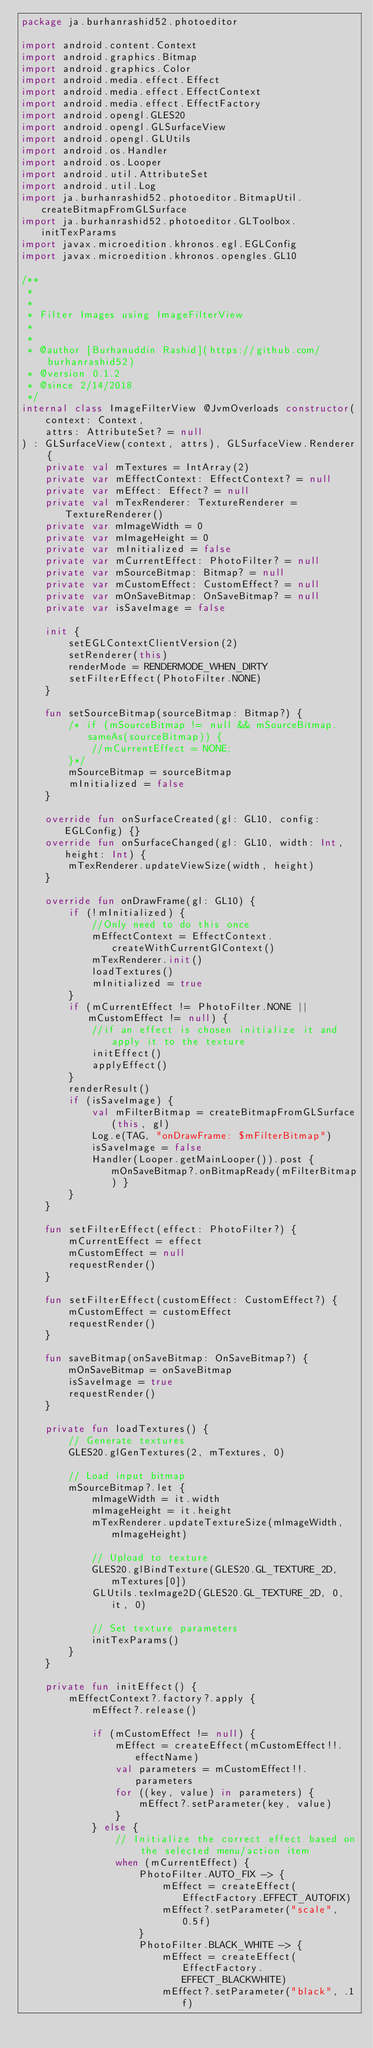<code> <loc_0><loc_0><loc_500><loc_500><_Kotlin_>package ja.burhanrashid52.photoeditor

import android.content.Context
import android.graphics.Bitmap
import android.graphics.Color
import android.media.effect.Effect
import android.media.effect.EffectContext
import android.media.effect.EffectFactory
import android.opengl.GLES20
import android.opengl.GLSurfaceView
import android.opengl.GLUtils
import android.os.Handler
import android.os.Looper
import android.util.AttributeSet
import android.util.Log
import ja.burhanrashid52.photoeditor.BitmapUtil.createBitmapFromGLSurface
import ja.burhanrashid52.photoeditor.GLToolbox.initTexParams
import javax.microedition.khronos.egl.EGLConfig
import javax.microedition.khronos.opengles.GL10

/**
 *
 *
 * Filter Images using ImageFilterView
 *
 *
 * @author [Burhanuddin Rashid](https://github.com/burhanrashid52)
 * @version 0.1.2
 * @since 2/14/2018
 */
internal class ImageFilterView @JvmOverloads constructor(
    context: Context,
    attrs: AttributeSet? = null
) : GLSurfaceView(context, attrs), GLSurfaceView.Renderer {
    private val mTextures = IntArray(2)
    private var mEffectContext: EffectContext? = null
    private var mEffect: Effect? = null
    private val mTexRenderer: TextureRenderer = TextureRenderer()
    private var mImageWidth = 0
    private var mImageHeight = 0
    private var mInitialized = false
    private var mCurrentEffect: PhotoFilter? = null
    private var mSourceBitmap: Bitmap? = null
    private var mCustomEffect: CustomEffect? = null
    private var mOnSaveBitmap: OnSaveBitmap? = null
    private var isSaveImage = false

    init {
        setEGLContextClientVersion(2)
        setRenderer(this)
        renderMode = RENDERMODE_WHEN_DIRTY
        setFilterEffect(PhotoFilter.NONE)
    }

    fun setSourceBitmap(sourceBitmap: Bitmap?) {
        /* if (mSourceBitmap != null && mSourceBitmap.sameAs(sourceBitmap)) {
            //mCurrentEffect = NONE;
        }*/
        mSourceBitmap = sourceBitmap
        mInitialized = false
    }

    override fun onSurfaceCreated(gl: GL10, config: EGLConfig) {}
    override fun onSurfaceChanged(gl: GL10, width: Int, height: Int) {
        mTexRenderer.updateViewSize(width, height)
    }

    override fun onDrawFrame(gl: GL10) {
        if (!mInitialized) {
            //Only need to do this once
            mEffectContext = EffectContext.createWithCurrentGlContext()
            mTexRenderer.init()
            loadTextures()
            mInitialized = true
        }
        if (mCurrentEffect != PhotoFilter.NONE || mCustomEffect != null) {
            //if an effect is chosen initialize it and apply it to the texture
            initEffect()
            applyEffect()
        }
        renderResult()
        if (isSaveImage) {
            val mFilterBitmap = createBitmapFromGLSurface(this, gl)
            Log.e(TAG, "onDrawFrame: $mFilterBitmap")
            isSaveImage = false
            Handler(Looper.getMainLooper()).post { mOnSaveBitmap?.onBitmapReady(mFilterBitmap) }
        }
    }

    fun setFilterEffect(effect: PhotoFilter?) {
        mCurrentEffect = effect
        mCustomEffect = null
        requestRender()
    }

    fun setFilterEffect(customEffect: CustomEffect?) {
        mCustomEffect = customEffect
        requestRender()
    }

    fun saveBitmap(onSaveBitmap: OnSaveBitmap?) {
        mOnSaveBitmap = onSaveBitmap
        isSaveImage = true
        requestRender()
    }

    private fun loadTextures() {
        // Generate textures
        GLES20.glGenTextures(2, mTextures, 0)

        // Load input bitmap
        mSourceBitmap?.let {
            mImageWidth = it.width
            mImageHeight = it.height
            mTexRenderer.updateTextureSize(mImageWidth, mImageHeight)

            // Upload to texture
            GLES20.glBindTexture(GLES20.GL_TEXTURE_2D, mTextures[0])
            GLUtils.texImage2D(GLES20.GL_TEXTURE_2D, 0, it, 0)

            // Set texture parameters
            initTexParams()
        }
    }

    private fun initEffect() {
        mEffectContext?.factory?.apply {
            mEffect?.release()

            if (mCustomEffect != null) {
                mEffect = createEffect(mCustomEffect!!.effectName)
                val parameters = mCustomEffect!!.parameters
                for ((key, value) in parameters) {
                    mEffect?.setParameter(key, value)
                }
            } else {
                // Initialize the correct effect based on the selected menu/action item
                when (mCurrentEffect) {
                    PhotoFilter.AUTO_FIX -> {
                        mEffect = createEffect(EffectFactory.EFFECT_AUTOFIX)
                        mEffect?.setParameter("scale", 0.5f)
                    }
                    PhotoFilter.BLACK_WHITE -> {
                        mEffect = createEffect(EffectFactory.EFFECT_BLACKWHITE)
                        mEffect?.setParameter("black", .1f)</code> 